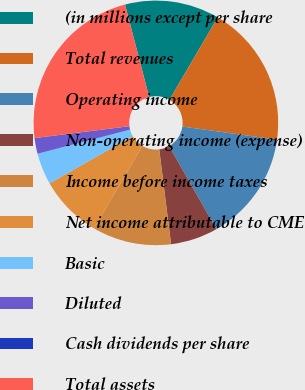<chart> <loc_0><loc_0><loc_500><loc_500><pie_chart><fcel>(in millions except per share<fcel>Total revenues<fcel>Operating income<fcel>Non-operating income (expense)<fcel>Income before income taxes<fcel>Net income attributable to CME<fcel>Basic<fcel>Diluted<fcel>Cash dividends per share<fcel>Total assets<nl><fcel>12.5%<fcel>18.75%<fcel>14.58%<fcel>6.25%<fcel>10.42%<fcel>8.33%<fcel>4.17%<fcel>2.08%<fcel>0.0%<fcel>22.92%<nl></chart> 